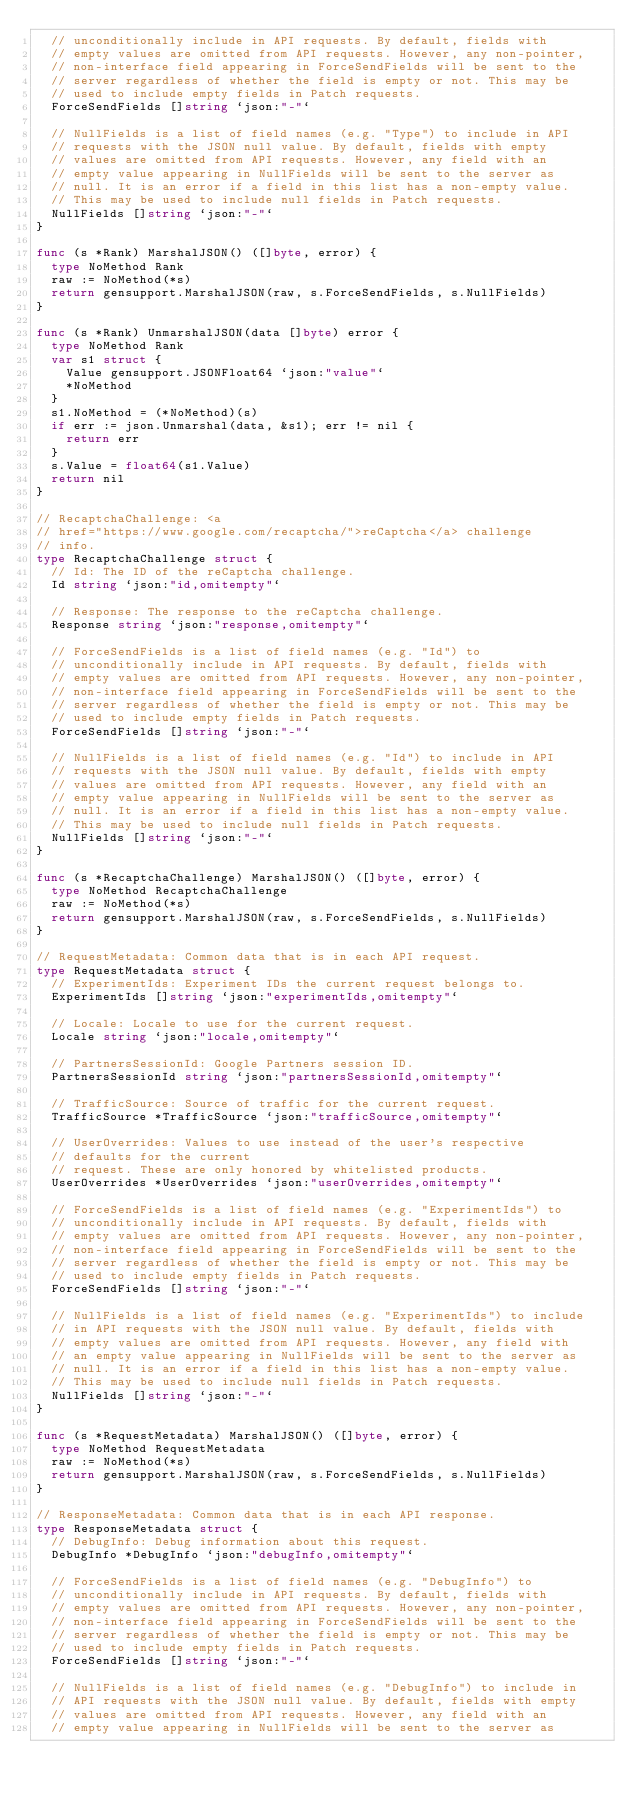Convert code to text. <code><loc_0><loc_0><loc_500><loc_500><_Go_>	// unconditionally include in API requests. By default, fields with
	// empty values are omitted from API requests. However, any non-pointer,
	// non-interface field appearing in ForceSendFields will be sent to the
	// server regardless of whether the field is empty or not. This may be
	// used to include empty fields in Patch requests.
	ForceSendFields []string `json:"-"`

	// NullFields is a list of field names (e.g. "Type") to include in API
	// requests with the JSON null value. By default, fields with empty
	// values are omitted from API requests. However, any field with an
	// empty value appearing in NullFields will be sent to the server as
	// null. It is an error if a field in this list has a non-empty value.
	// This may be used to include null fields in Patch requests.
	NullFields []string `json:"-"`
}

func (s *Rank) MarshalJSON() ([]byte, error) {
	type NoMethod Rank
	raw := NoMethod(*s)
	return gensupport.MarshalJSON(raw, s.ForceSendFields, s.NullFields)
}

func (s *Rank) UnmarshalJSON(data []byte) error {
	type NoMethod Rank
	var s1 struct {
		Value gensupport.JSONFloat64 `json:"value"`
		*NoMethod
	}
	s1.NoMethod = (*NoMethod)(s)
	if err := json.Unmarshal(data, &s1); err != nil {
		return err
	}
	s.Value = float64(s1.Value)
	return nil
}

// RecaptchaChallenge: <a
// href="https://www.google.com/recaptcha/">reCaptcha</a> challenge
// info.
type RecaptchaChallenge struct {
	// Id: The ID of the reCaptcha challenge.
	Id string `json:"id,omitempty"`

	// Response: The response to the reCaptcha challenge.
	Response string `json:"response,omitempty"`

	// ForceSendFields is a list of field names (e.g. "Id") to
	// unconditionally include in API requests. By default, fields with
	// empty values are omitted from API requests. However, any non-pointer,
	// non-interface field appearing in ForceSendFields will be sent to the
	// server regardless of whether the field is empty or not. This may be
	// used to include empty fields in Patch requests.
	ForceSendFields []string `json:"-"`

	// NullFields is a list of field names (e.g. "Id") to include in API
	// requests with the JSON null value. By default, fields with empty
	// values are omitted from API requests. However, any field with an
	// empty value appearing in NullFields will be sent to the server as
	// null. It is an error if a field in this list has a non-empty value.
	// This may be used to include null fields in Patch requests.
	NullFields []string `json:"-"`
}

func (s *RecaptchaChallenge) MarshalJSON() ([]byte, error) {
	type NoMethod RecaptchaChallenge
	raw := NoMethod(*s)
	return gensupport.MarshalJSON(raw, s.ForceSendFields, s.NullFields)
}

// RequestMetadata: Common data that is in each API request.
type RequestMetadata struct {
	// ExperimentIds: Experiment IDs the current request belongs to.
	ExperimentIds []string `json:"experimentIds,omitempty"`

	// Locale: Locale to use for the current request.
	Locale string `json:"locale,omitempty"`

	// PartnersSessionId: Google Partners session ID.
	PartnersSessionId string `json:"partnersSessionId,omitempty"`

	// TrafficSource: Source of traffic for the current request.
	TrafficSource *TrafficSource `json:"trafficSource,omitempty"`

	// UserOverrides: Values to use instead of the user's respective
	// defaults for the current
	// request. These are only honored by whitelisted products.
	UserOverrides *UserOverrides `json:"userOverrides,omitempty"`

	// ForceSendFields is a list of field names (e.g. "ExperimentIds") to
	// unconditionally include in API requests. By default, fields with
	// empty values are omitted from API requests. However, any non-pointer,
	// non-interface field appearing in ForceSendFields will be sent to the
	// server regardless of whether the field is empty or not. This may be
	// used to include empty fields in Patch requests.
	ForceSendFields []string `json:"-"`

	// NullFields is a list of field names (e.g. "ExperimentIds") to include
	// in API requests with the JSON null value. By default, fields with
	// empty values are omitted from API requests. However, any field with
	// an empty value appearing in NullFields will be sent to the server as
	// null. It is an error if a field in this list has a non-empty value.
	// This may be used to include null fields in Patch requests.
	NullFields []string `json:"-"`
}

func (s *RequestMetadata) MarshalJSON() ([]byte, error) {
	type NoMethod RequestMetadata
	raw := NoMethod(*s)
	return gensupport.MarshalJSON(raw, s.ForceSendFields, s.NullFields)
}

// ResponseMetadata: Common data that is in each API response.
type ResponseMetadata struct {
	// DebugInfo: Debug information about this request.
	DebugInfo *DebugInfo `json:"debugInfo,omitempty"`

	// ForceSendFields is a list of field names (e.g. "DebugInfo") to
	// unconditionally include in API requests. By default, fields with
	// empty values are omitted from API requests. However, any non-pointer,
	// non-interface field appearing in ForceSendFields will be sent to the
	// server regardless of whether the field is empty or not. This may be
	// used to include empty fields in Patch requests.
	ForceSendFields []string `json:"-"`

	// NullFields is a list of field names (e.g. "DebugInfo") to include in
	// API requests with the JSON null value. By default, fields with empty
	// values are omitted from API requests. However, any field with an
	// empty value appearing in NullFields will be sent to the server as</code> 